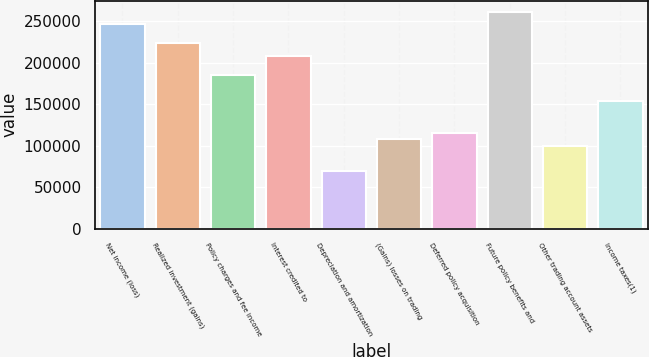<chart> <loc_0><loc_0><loc_500><loc_500><bar_chart><fcel>Net income (loss)<fcel>Realized investment (gains)<fcel>Policy charges and fee income<fcel>Interest credited to<fcel>Depreciation and amortization<fcel>(Gains) losses on trading<fcel>Deferred policy acquisition<fcel>Future policy benefits and<fcel>Other trading account assets<fcel>Income taxes(1)<nl><fcel>246467<fcel>223360<fcel>184850<fcel>207956<fcel>69318.9<fcel>107829<fcel>115531<fcel>261871<fcel>100127<fcel>154042<nl></chart> 